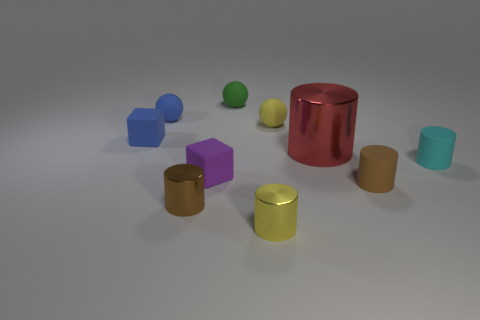Subtract all purple cylinders. Subtract all purple spheres. How many cylinders are left? 5 Subtract all cubes. How many objects are left? 8 Add 2 small cyan things. How many small cyan things are left? 3 Add 1 small purple objects. How many small purple objects exist? 2 Subtract 0 purple spheres. How many objects are left? 10 Subtract all yellow shiny cylinders. Subtract all brown cylinders. How many objects are left? 7 